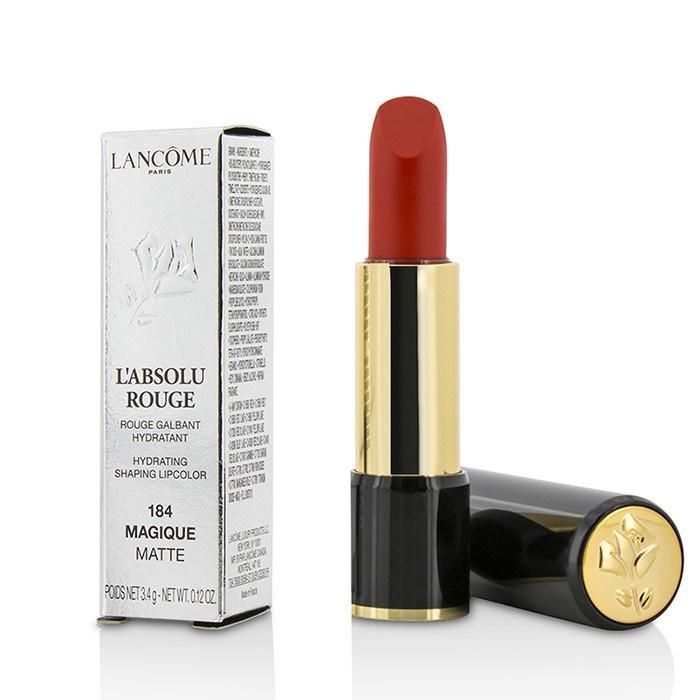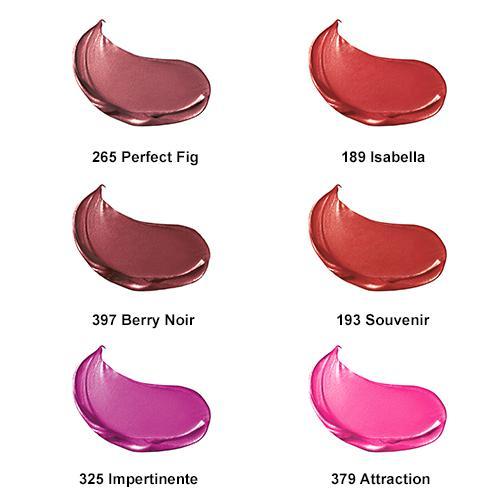The first image is the image on the left, the second image is the image on the right. Examine the images to the left and right. Is the description "There are 6 shades of lipstick presented in the image on the right." accurate? Answer yes or no. Yes. The first image is the image on the left, the second image is the image on the right. For the images displayed, is the sentence "One image shows exactly six different lipstick color samples." factually correct? Answer yes or no. Yes. 